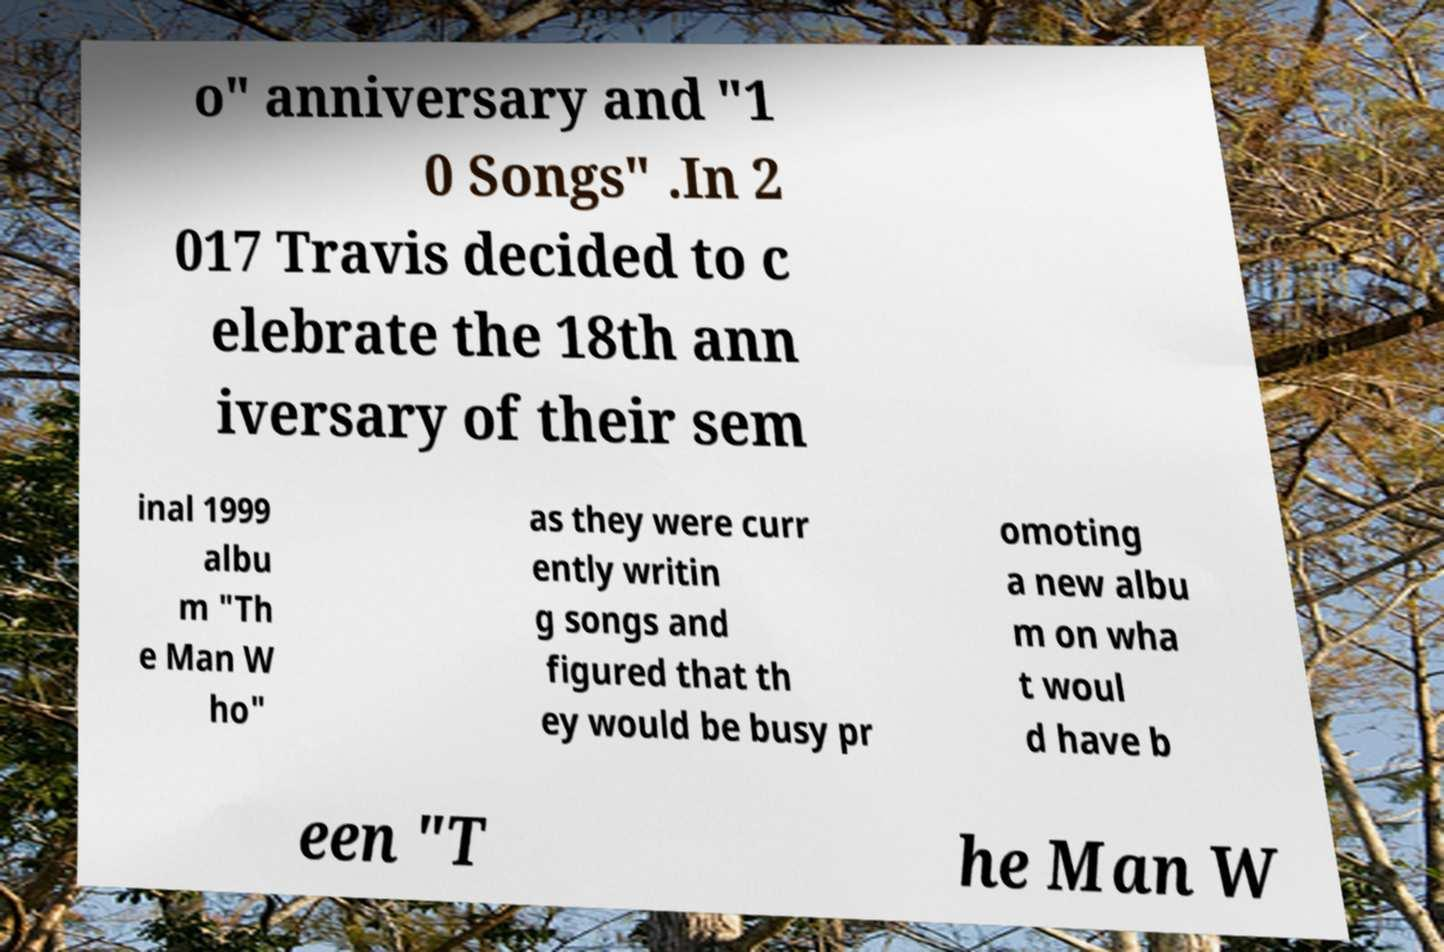What messages or text are displayed in this image? I need them in a readable, typed format. o" anniversary and "1 0 Songs" .In 2 017 Travis decided to c elebrate the 18th ann iversary of their sem inal 1999 albu m "Th e Man W ho" as they were curr ently writin g songs and figured that th ey would be busy pr omoting a new albu m on wha t woul d have b een "T he Man W 